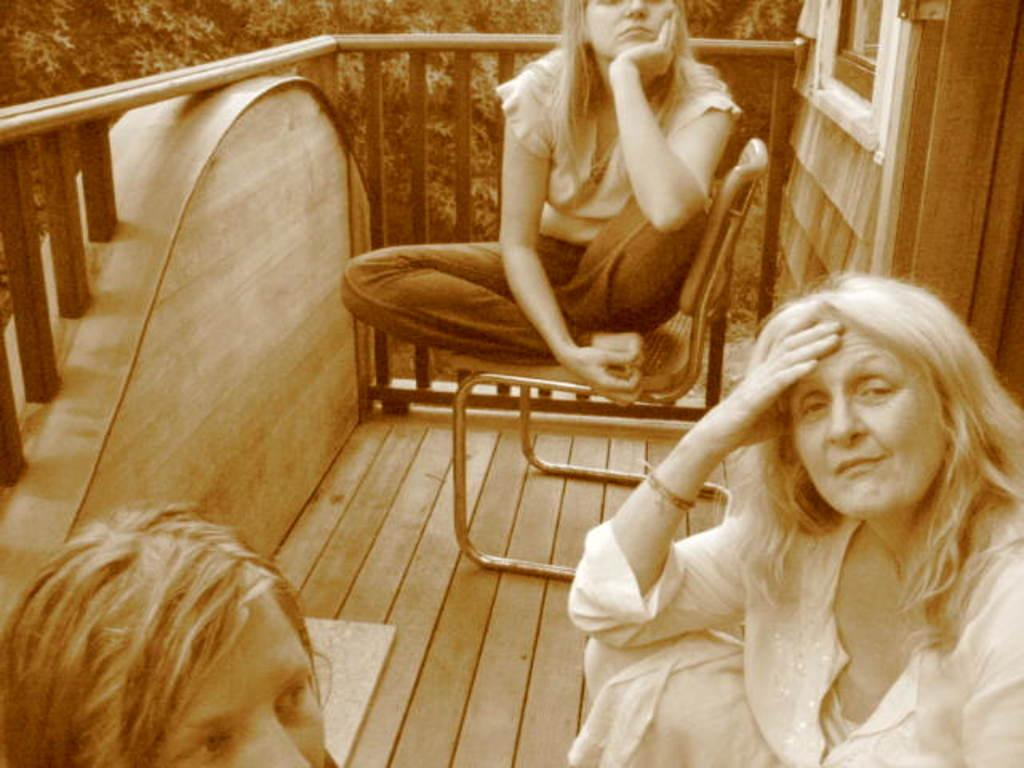How many people are present in the image? There are three people in the image. What is the woman in the image doing? The woman is sitting on a chair. What type of flooring is visible at the bottom of the image? There is a wooden floor at the bottom of the image. What architectural features can be seen in the background of the image? There are railings and a wall in the background of the image. What can be seen through the window in the background of the image? Trees are visible in the background of the image. What time of day is indicated by the hour on the clock in the image? There is no clock present in the image, so it is not possible to determine the time of day. Can you tell me how many donkeys are visible in the image? There are no donkeys present in the image. What type of needle is being used by the woman in the image? There is no needle present in the image, and the woman is sitting on a chair, not performing any activity that would involve a needle. 